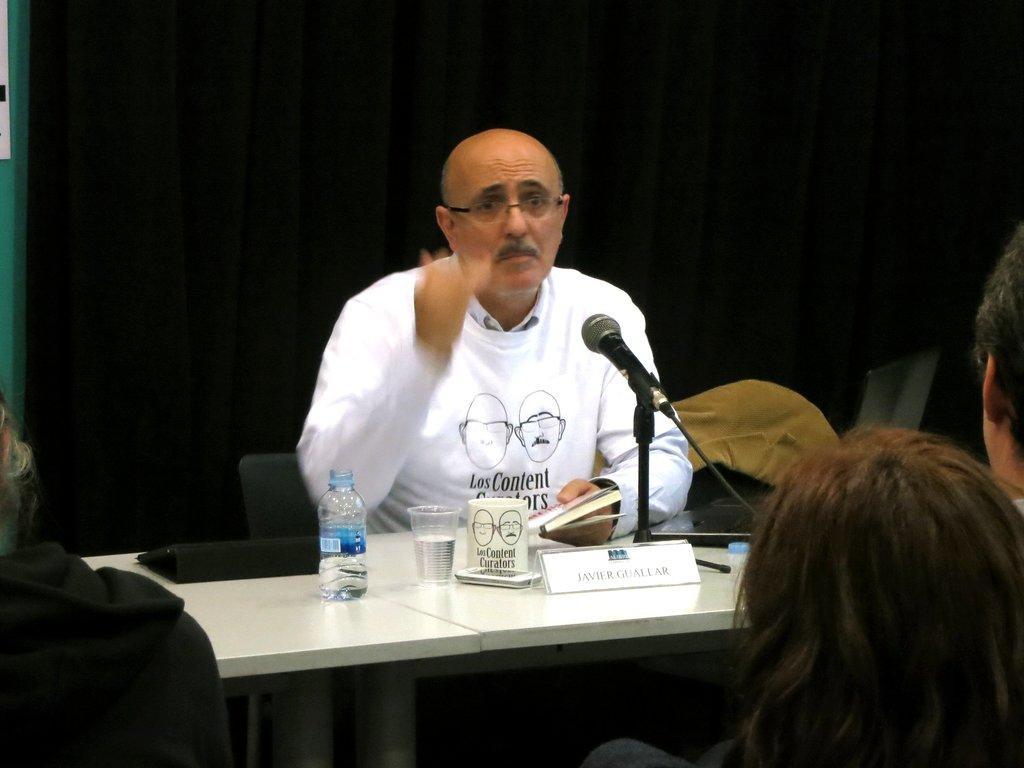How would you summarize this image in a sentence or two? In the center of the picture there is a desk, on the desk there is a mic, cup glass, bottle, file, name plate and a book. In the center of the picture there is a man in white dress, he is sitting on a chair. In the background there is a black curtain. In the foreground people seated. 